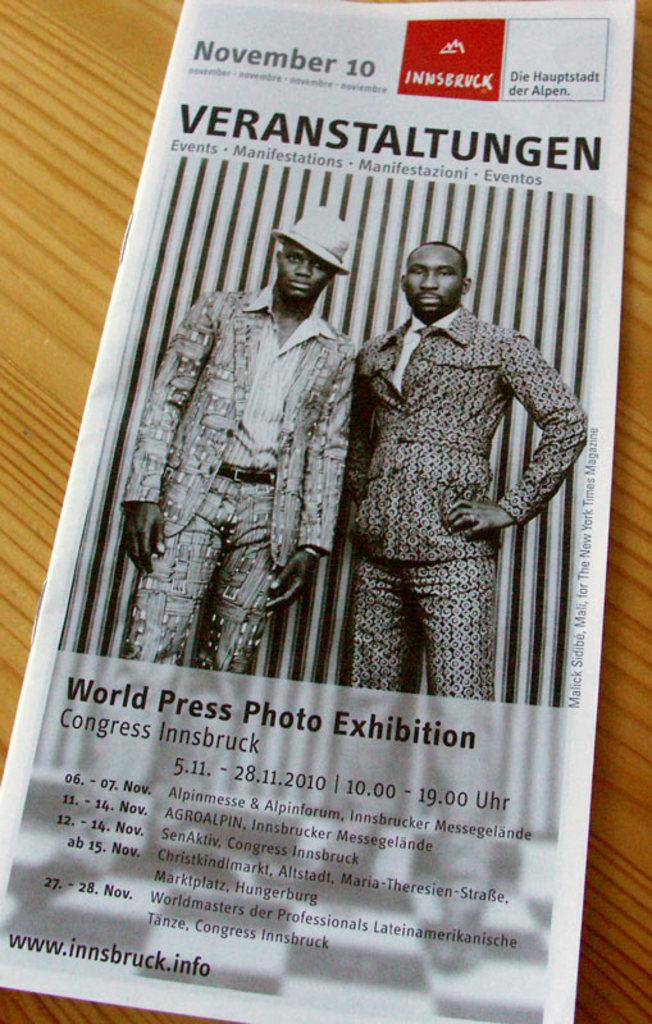What object is placed on the table in the image? There is a brochure on a table in the image. What might the brochure contain or be about? The brochure might contain information about a location, event, or service. What is the purpose of the brochure in the image? The brochure could be for informational or promotional purposes. How does the brochure contribute to the comfort of the room in the image? The brochure's presence does not directly contribute to the comfort of the room; it is an informational object. 